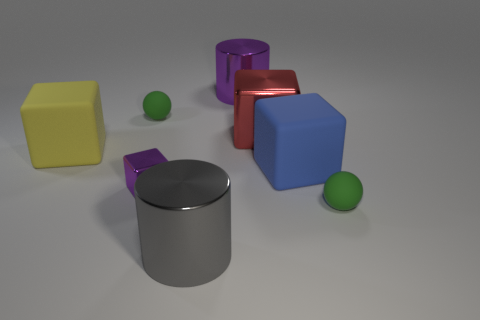Subtract all blue rubber blocks. How many blocks are left? 3 Subtract all blue blocks. How many blocks are left? 3 Subtract 1 cubes. How many cubes are left? 3 Subtract all brown blocks. Subtract all red cylinders. How many blocks are left? 4 Add 2 big yellow matte cubes. How many objects exist? 10 Subtract 0 brown cylinders. How many objects are left? 8 Subtract all cylinders. How many objects are left? 6 Subtract all small blue matte balls. Subtract all blue matte objects. How many objects are left? 7 Add 3 large things. How many large things are left? 8 Add 6 large blue things. How many large blue things exist? 7 